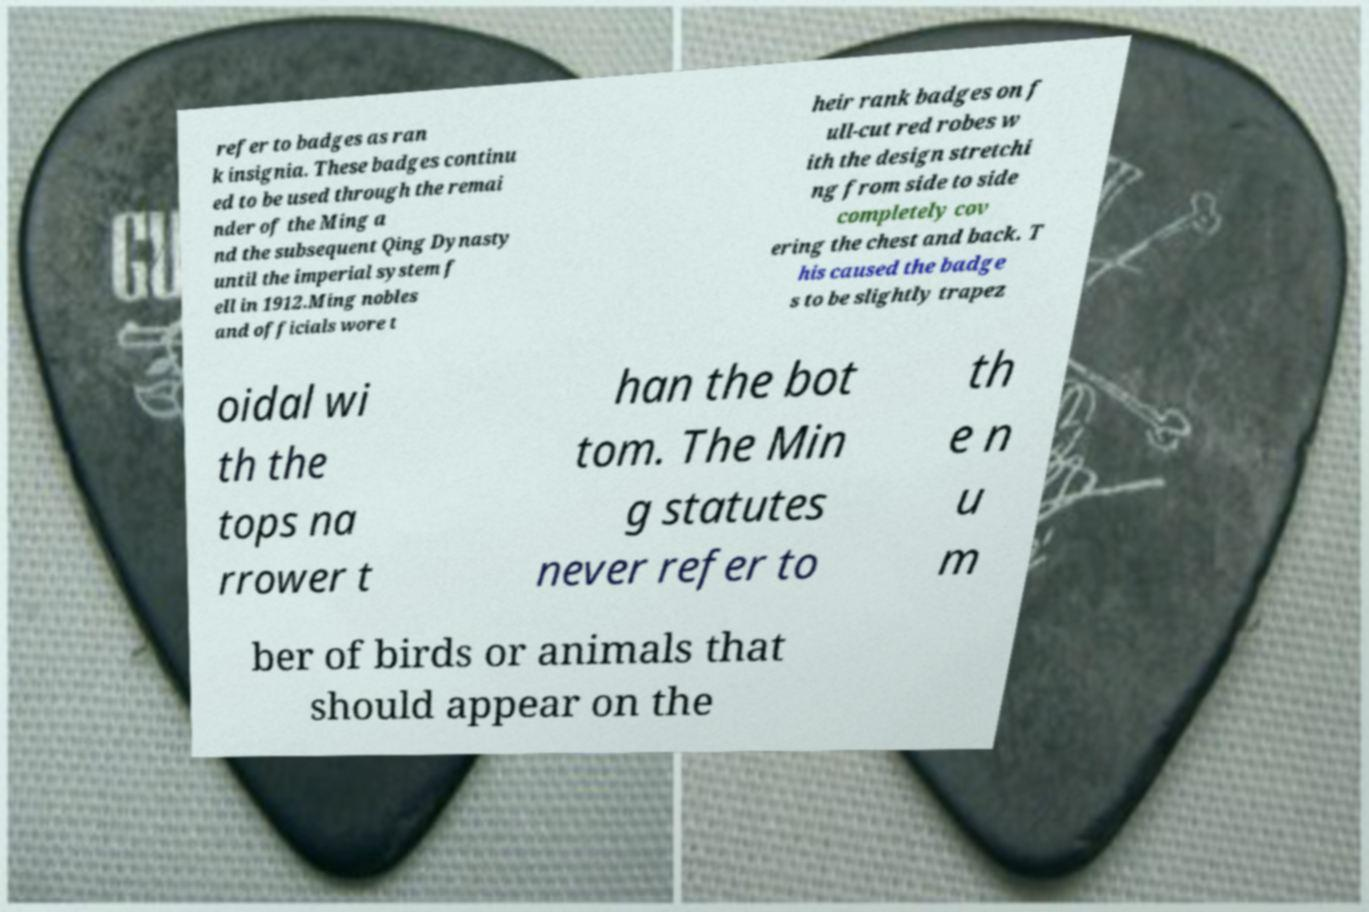Could you extract and type out the text from this image? refer to badges as ran k insignia. These badges continu ed to be used through the remai nder of the Ming a nd the subsequent Qing Dynasty until the imperial system f ell in 1912.Ming nobles and officials wore t heir rank badges on f ull-cut red robes w ith the design stretchi ng from side to side completely cov ering the chest and back. T his caused the badge s to be slightly trapez oidal wi th the tops na rrower t han the bot tom. The Min g statutes never refer to th e n u m ber of birds or animals that should appear on the 